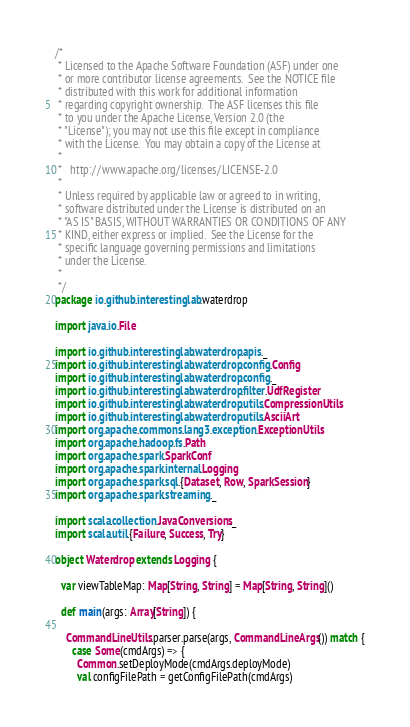<code> <loc_0><loc_0><loc_500><loc_500><_Scala_>/*
 * Licensed to the Apache Software Foundation (ASF) under one
 * or more contributor license agreements.  See the NOTICE file
 * distributed with this work for additional information
 * regarding copyright ownership.  The ASF licenses this file
 * to you under the Apache License, Version 2.0 (the
 * "License"); you may not use this file except in compliance
 * with the License.  You may obtain a copy of the License at
 *
 *   http://www.apache.org/licenses/LICENSE-2.0
 *
 * Unless required by applicable law or agreed to in writing,
 * software distributed under the License is distributed on an
 * "AS IS" BASIS, WITHOUT WARRANTIES OR CONDITIONS OF ANY
 * KIND, either express or implied.  See the License for the
 * specific language governing permissions and limitations
 * under the License.
 *
 */
package io.github.interestinglab.waterdrop

import java.io.File

import io.github.interestinglab.waterdrop.apis._
import io.github.interestinglab.waterdrop.config.Config
import io.github.interestinglab.waterdrop.config._
import io.github.interestinglab.waterdrop.filter.UdfRegister
import io.github.interestinglab.waterdrop.utils.CompressionUtils
import io.github.interestinglab.waterdrop.utils.AsciiArt
import org.apache.commons.lang3.exception.ExceptionUtils
import org.apache.hadoop.fs.Path
import org.apache.spark.SparkConf
import org.apache.spark.internal.Logging
import org.apache.spark.sql.{Dataset, Row, SparkSession}
import org.apache.spark.streaming._

import scala.collection.JavaConversions._
import scala.util.{Failure, Success, Try}

object Waterdrop extends Logging {

  var viewTableMap: Map[String, String] = Map[String, String]()

  def main(args: Array[String]) {

    CommandLineUtils.parser.parse(args, CommandLineArgs()) match {
      case Some(cmdArgs) => {
        Common.setDeployMode(cmdArgs.deployMode)
        val configFilePath = getConfigFilePath(cmdArgs)
</code> 